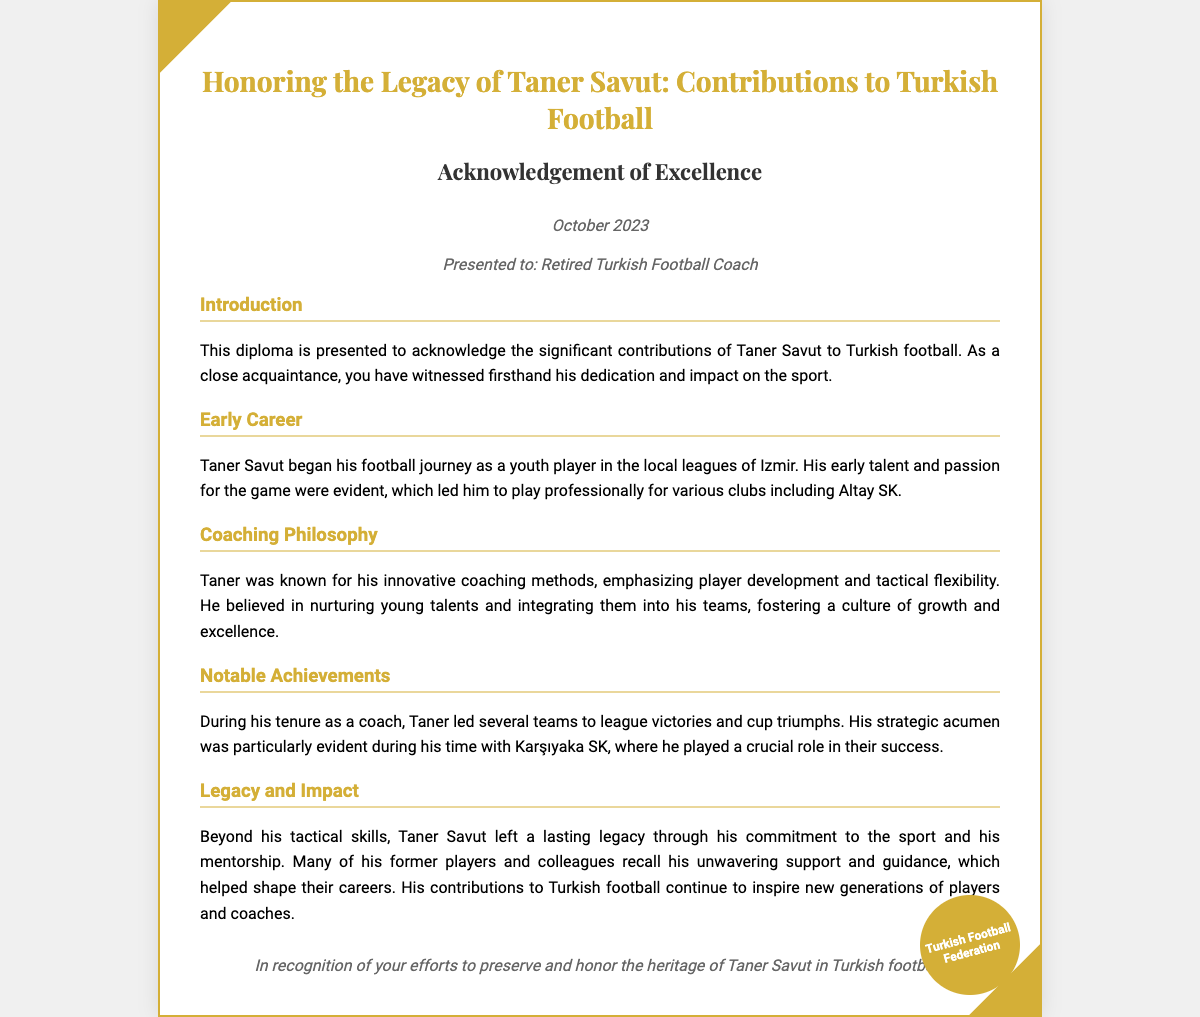What is the title of the diploma? The title of the diploma is explicitly mentioned at the beginning of the document.
Answer: Honoring the Legacy of Taner Savut: Contributions to Turkish Football Who is the diploma presented to? The document specifies the recipient of the diploma.
Answer: Retired Turkish Football Coach When was the diploma issued? The date of issuance is clearly stated in the document.
Answer: October 2023 What club did Taner Savut play for professionally? The document lists one of the clubs where Taner Savut played.
Answer: Altay SK Which team did Taner coach to notable success? The section on notable achievements highlights a specific team he coached.
Answer: Karşıyaka SK What aspect of coaching did Taner Savut emphasize? The coaching philosophy section outlines what Taner Savut focused on in his methods.
Answer: Player development What legacy did Taner Savut leave behind? The legacy section describes the lasting impact of Taner's life and work in football.
Answer: Commitment to the sport and mentorship Who issued this diploma? The seal at the bottom of the document identifies the issuing authority.
Answer: Turkish Football Federation 